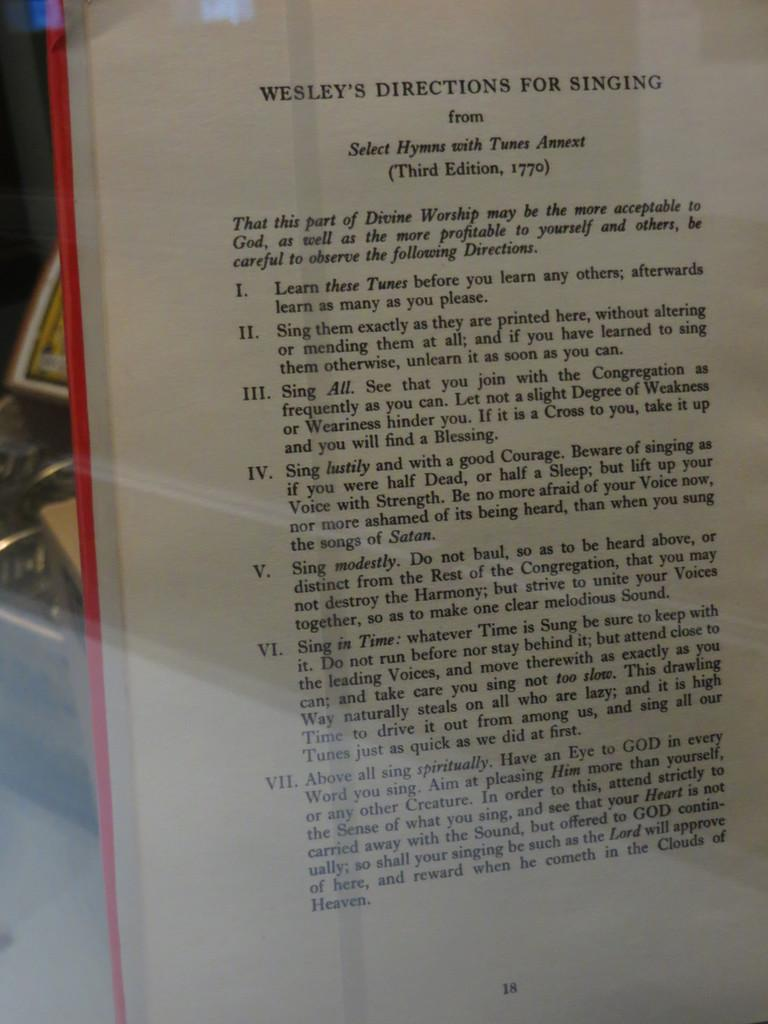<image>
Offer a succinct explanation of the picture presented. Wesley's Direction for singing third edition chapter book 